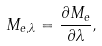<formula> <loc_0><loc_0><loc_500><loc_500>M _ { e , \lambda } = { \frac { \partial M _ { e } } { \partial \lambda } } ,</formula> 